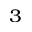<formula> <loc_0><loc_0><loc_500><loc_500>^ { 3 }</formula> 